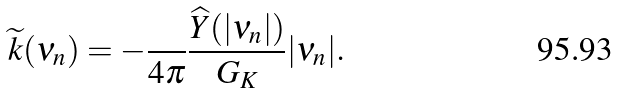Convert formula to latex. <formula><loc_0><loc_0><loc_500><loc_500>\widetilde { k } ( \nu _ { n } ) = - \frac { } { 4 \pi } \frac { \widehat { Y } ( | \nu _ { n } | ) } { G _ { K } } | \nu _ { n } | .</formula> 